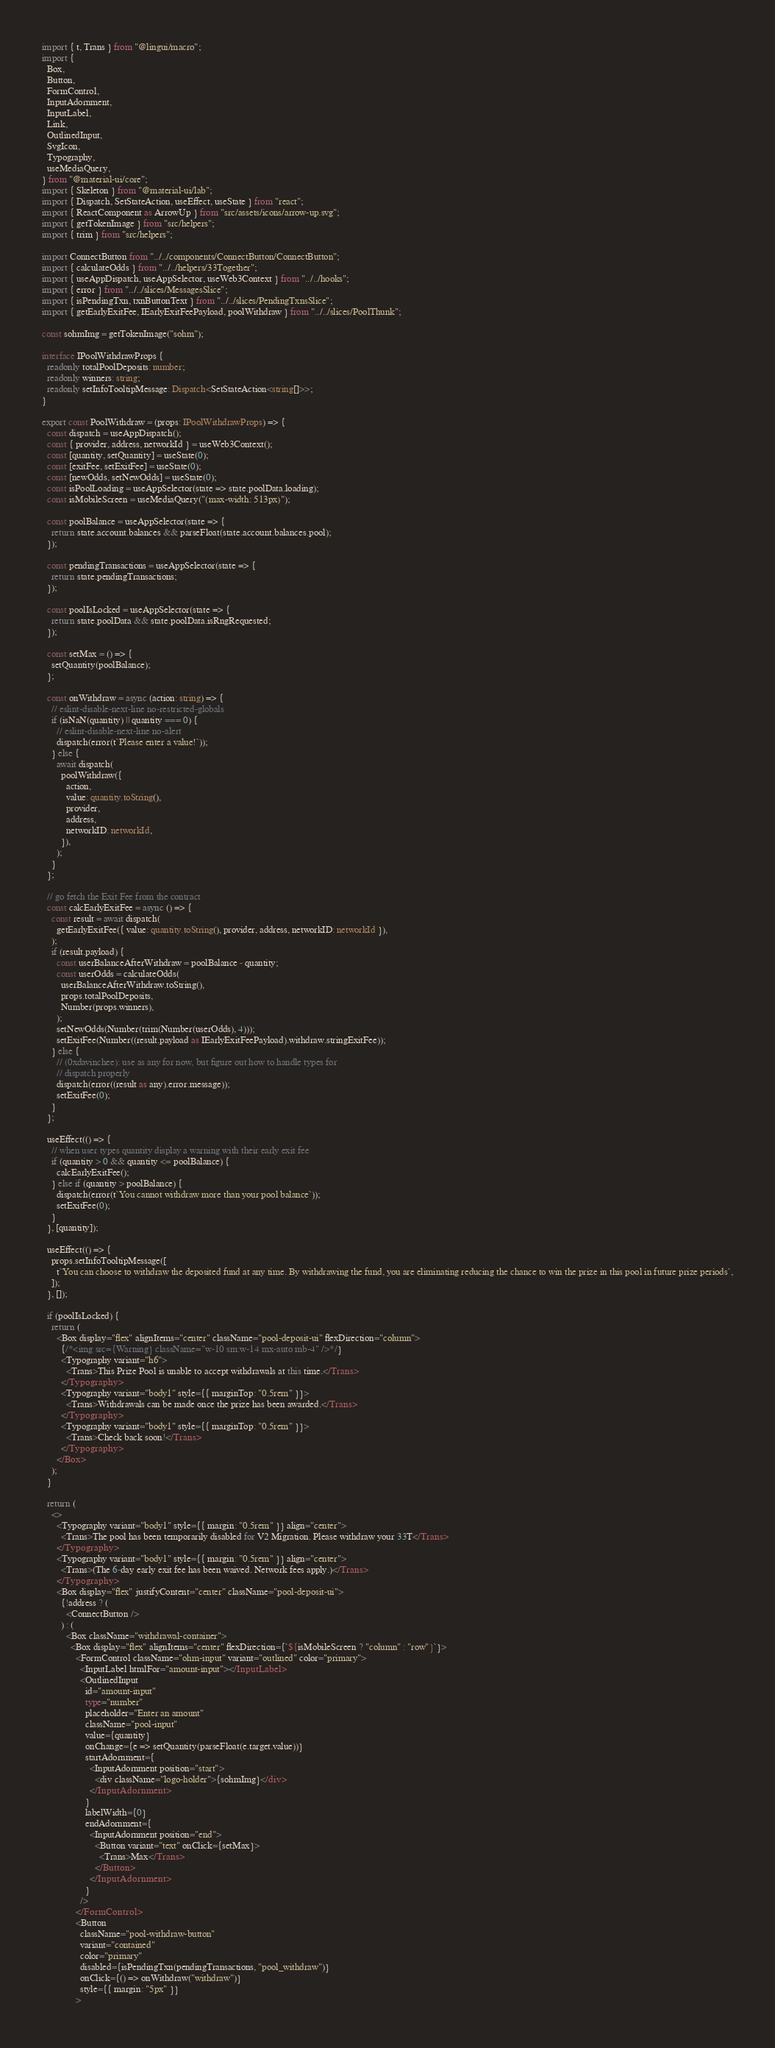Convert code to text. <code><loc_0><loc_0><loc_500><loc_500><_TypeScript_>import { t, Trans } from "@lingui/macro";
import {
  Box,
  Button,
  FormControl,
  InputAdornment,
  InputLabel,
  Link,
  OutlinedInput,
  SvgIcon,
  Typography,
  useMediaQuery,
} from "@material-ui/core";
import { Skeleton } from "@material-ui/lab";
import { Dispatch, SetStateAction, useEffect, useState } from "react";
import { ReactComponent as ArrowUp } from "src/assets/icons/arrow-up.svg";
import { getTokenImage } from "src/helpers";
import { trim } from "src/helpers";

import ConnectButton from "../../components/ConnectButton/ConnectButton";
import { calculateOdds } from "../../helpers/33Together";
import { useAppDispatch, useAppSelector, useWeb3Context } from "../../hooks";
import { error } from "../../slices/MessagesSlice";
import { isPendingTxn, txnButtonText } from "../../slices/PendingTxnsSlice";
import { getEarlyExitFee, IEarlyExitFeePayload, poolWithdraw } from "../../slices/PoolThunk";

const sohmImg = getTokenImage("sohm");

interface IPoolWithdrawProps {
  readonly totalPoolDeposits: number;
  readonly winners: string;
  readonly setInfoTooltipMessage: Dispatch<SetStateAction<string[]>>;
}

export const PoolWithdraw = (props: IPoolWithdrawProps) => {
  const dispatch = useAppDispatch();
  const { provider, address, networkId } = useWeb3Context();
  const [quantity, setQuantity] = useState(0);
  const [exitFee, setExitFee] = useState(0);
  const [newOdds, setNewOdds] = useState(0);
  const isPoolLoading = useAppSelector(state => state.poolData.loading);
  const isMobileScreen = useMediaQuery("(max-width: 513px)");

  const poolBalance = useAppSelector(state => {
    return state.account.balances && parseFloat(state.account.balances.pool);
  });

  const pendingTransactions = useAppSelector(state => {
    return state.pendingTransactions;
  });

  const poolIsLocked = useAppSelector(state => {
    return state.poolData && state.poolData.isRngRequested;
  });

  const setMax = () => {
    setQuantity(poolBalance);
  };

  const onWithdraw = async (action: string) => {
    // eslint-disable-next-line no-restricted-globals
    if (isNaN(quantity) || quantity === 0) {
      // eslint-disable-next-line no-alert
      dispatch(error(t`Please enter a value!`));
    } else {
      await dispatch(
        poolWithdraw({
          action,
          value: quantity.toString(),
          provider,
          address,
          networkID: networkId,
        }),
      );
    }
  };

  // go fetch the Exit Fee from the contract
  const calcEarlyExitFee = async () => {
    const result = await dispatch(
      getEarlyExitFee({ value: quantity.toString(), provider, address, networkID: networkId }),
    );
    if (result.payload) {
      const userBalanceAfterWithdraw = poolBalance - quantity;
      const userOdds = calculateOdds(
        userBalanceAfterWithdraw.toString(),
        props.totalPoolDeposits,
        Number(props.winners),
      );
      setNewOdds(Number(trim(Number(userOdds), 4)));
      setExitFee(Number((result.payload as IEarlyExitFeePayload).withdraw.stringExitFee));
    } else {
      // (0xdavinchee): use as any for now, but figure out how to handle types for
      // dispatch properly
      dispatch(error((result as any).error.message));
      setExitFee(0);
    }
  };

  useEffect(() => {
    // when user types quantity display a warning with their early exit fee
    if (quantity > 0 && quantity <= poolBalance) {
      calcEarlyExitFee();
    } else if (quantity > poolBalance) {
      dispatch(error(t`You cannot withdraw more than your pool balance`));
      setExitFee(0);
    }
  }, [quantity]);

  useEffect(() => {
    props.setInfoTooltipMessage([
      t`You can choose to withdraw the deposited fund at any time. By withdrawing the fund, you are eliminating reducing the chance to win the prize in this pool in future prize periods`,
    ]);
  }, []);

  if (poolIsLocked) {
    return (
      <Box display="flex" alignItems="center" className="pool-deposit-ui" flexDirection="column">
        {/*<img src={Warning} className="w-10 sm:w-14 mx-auto mb-4" />*/}
        <Typography variant="h6">
          <Trans>This Prize Pool is unable to accept withdrawals at this time.</Trans>
        </Typography>
        <Typography variant="body1" style={{ marginTop: "0.5rem" }}>
          <Trans>Withdrawals can be made once the prize has been awarded.</Trans>
        </Typography>
        <Typography variant="body1" style={{ marginTop: "0.5rem" }}>
          <Trans>Check back soon!</Trans>
        </Typography>
      </Box>
    );
  }

  return (
    <>
      <Typography variant="body1" style={{ margin: "0.5rem" }} align="center">
        <Trans>The pool has been temporarily disabled for V2 Migration. Please withdraw your 33T</Trans>
      </Typography>
      <Typography variant="body1" style={{ margin: "0.5rem" }} align="center">
        <Trans>(The 6-day early exit fee has been waived. Network fees apply.)</Trans>
      </Typography>
      <Box display="flex" justifyContent="center" className="pool-deposit-ui">
        {!address ? (
          <ConnectButton />
        ) : (
          <Box className="withdrawal-container">
            <Box display="flex" alignItems="center" flexDirection={`${isMobileScreen ? "column" : "row"}`}>
              <FormControl className="ohm-input" variant="outlined" color="primary">
                <InputLabel htmlFor="amount-input"></InputLabel>
                <OutlinedInput
                  id="amount-input"
                  type="number"
                  placeholder="Enter an amount"
                  className="pool-input"
                  value={quantity}
                  onChange={e => setQuantity(parseFloat(e.target.value))}
                  startAdornment={
                    <InputAdornment position="start">
                      <div className="logo-holder">{sohmImg}</div>
                    </InputAdornment>
                  }
                  labelWidth={0}
                  endAdornment={
                    <InputAdornment position="end">
                      <Button variant="text" onClick={setMax}>
                        <Trans>Max</Trans>
                      </Button>
                    </InputAdornment>
                  }
                />
              </FormControl>
              <Button
                className="pool-withdraw-button"
                variant="contained"
                color="primary"
                disabled={isPendingTxn(pendingTransactions, "pool_withdraw")}
                onClick={() => onWithdraw("withdraw")}
                style={{ margin: "5px" }}
              ></code> 